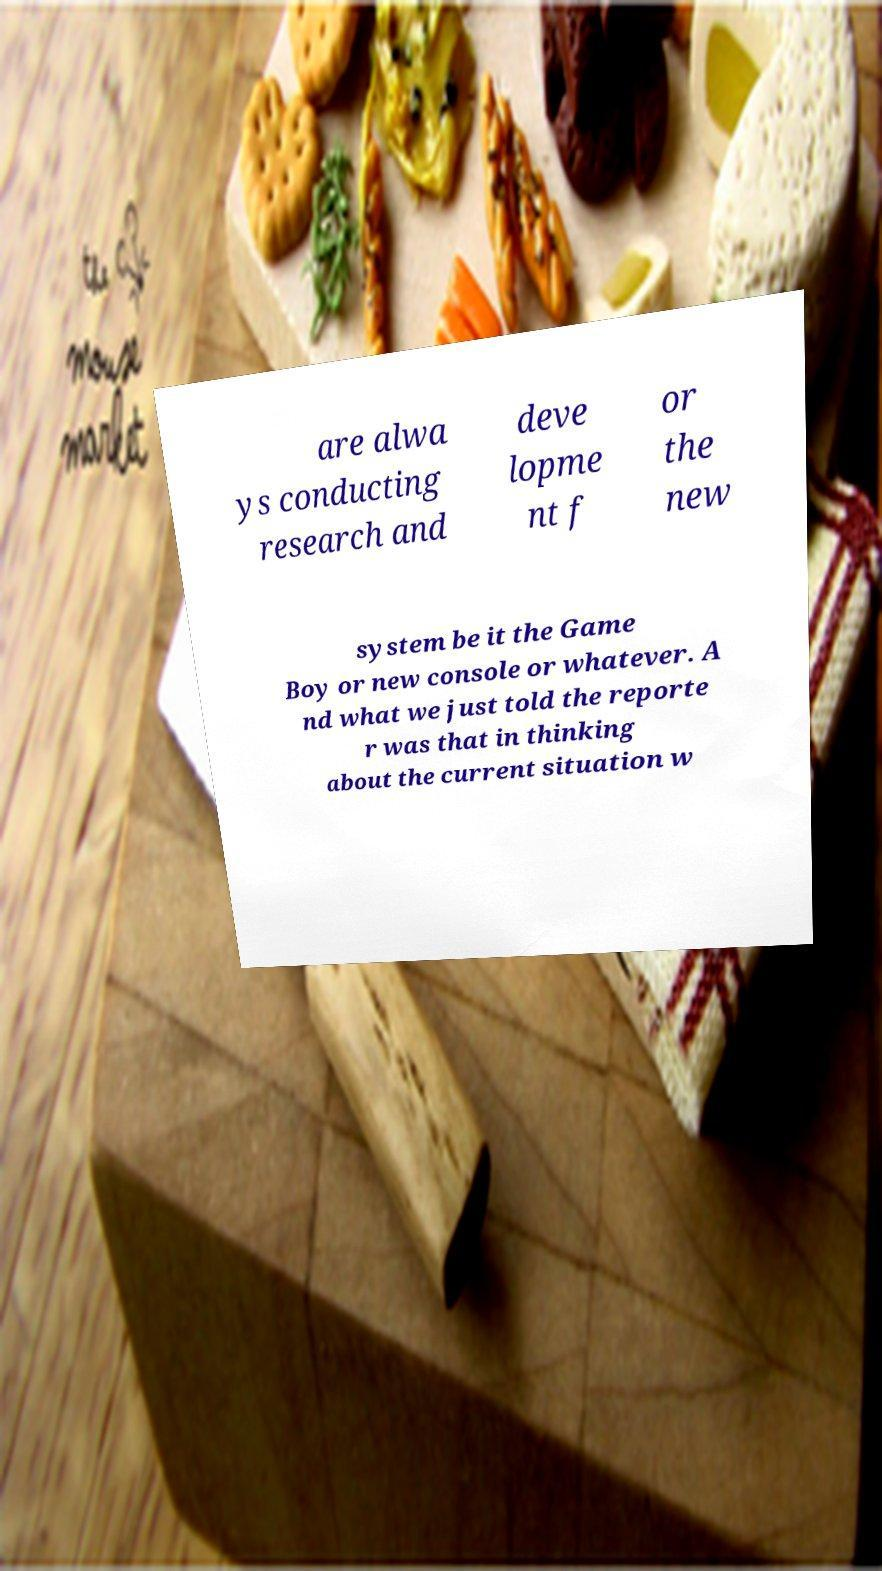Please identify and transcribe the text found in this image. are alwa ys conducting research and deve lopme nt f or the new system be it the Game Boy or new console or whatever. A nd what we just told the reporte r was that in thinking about the current situation w 